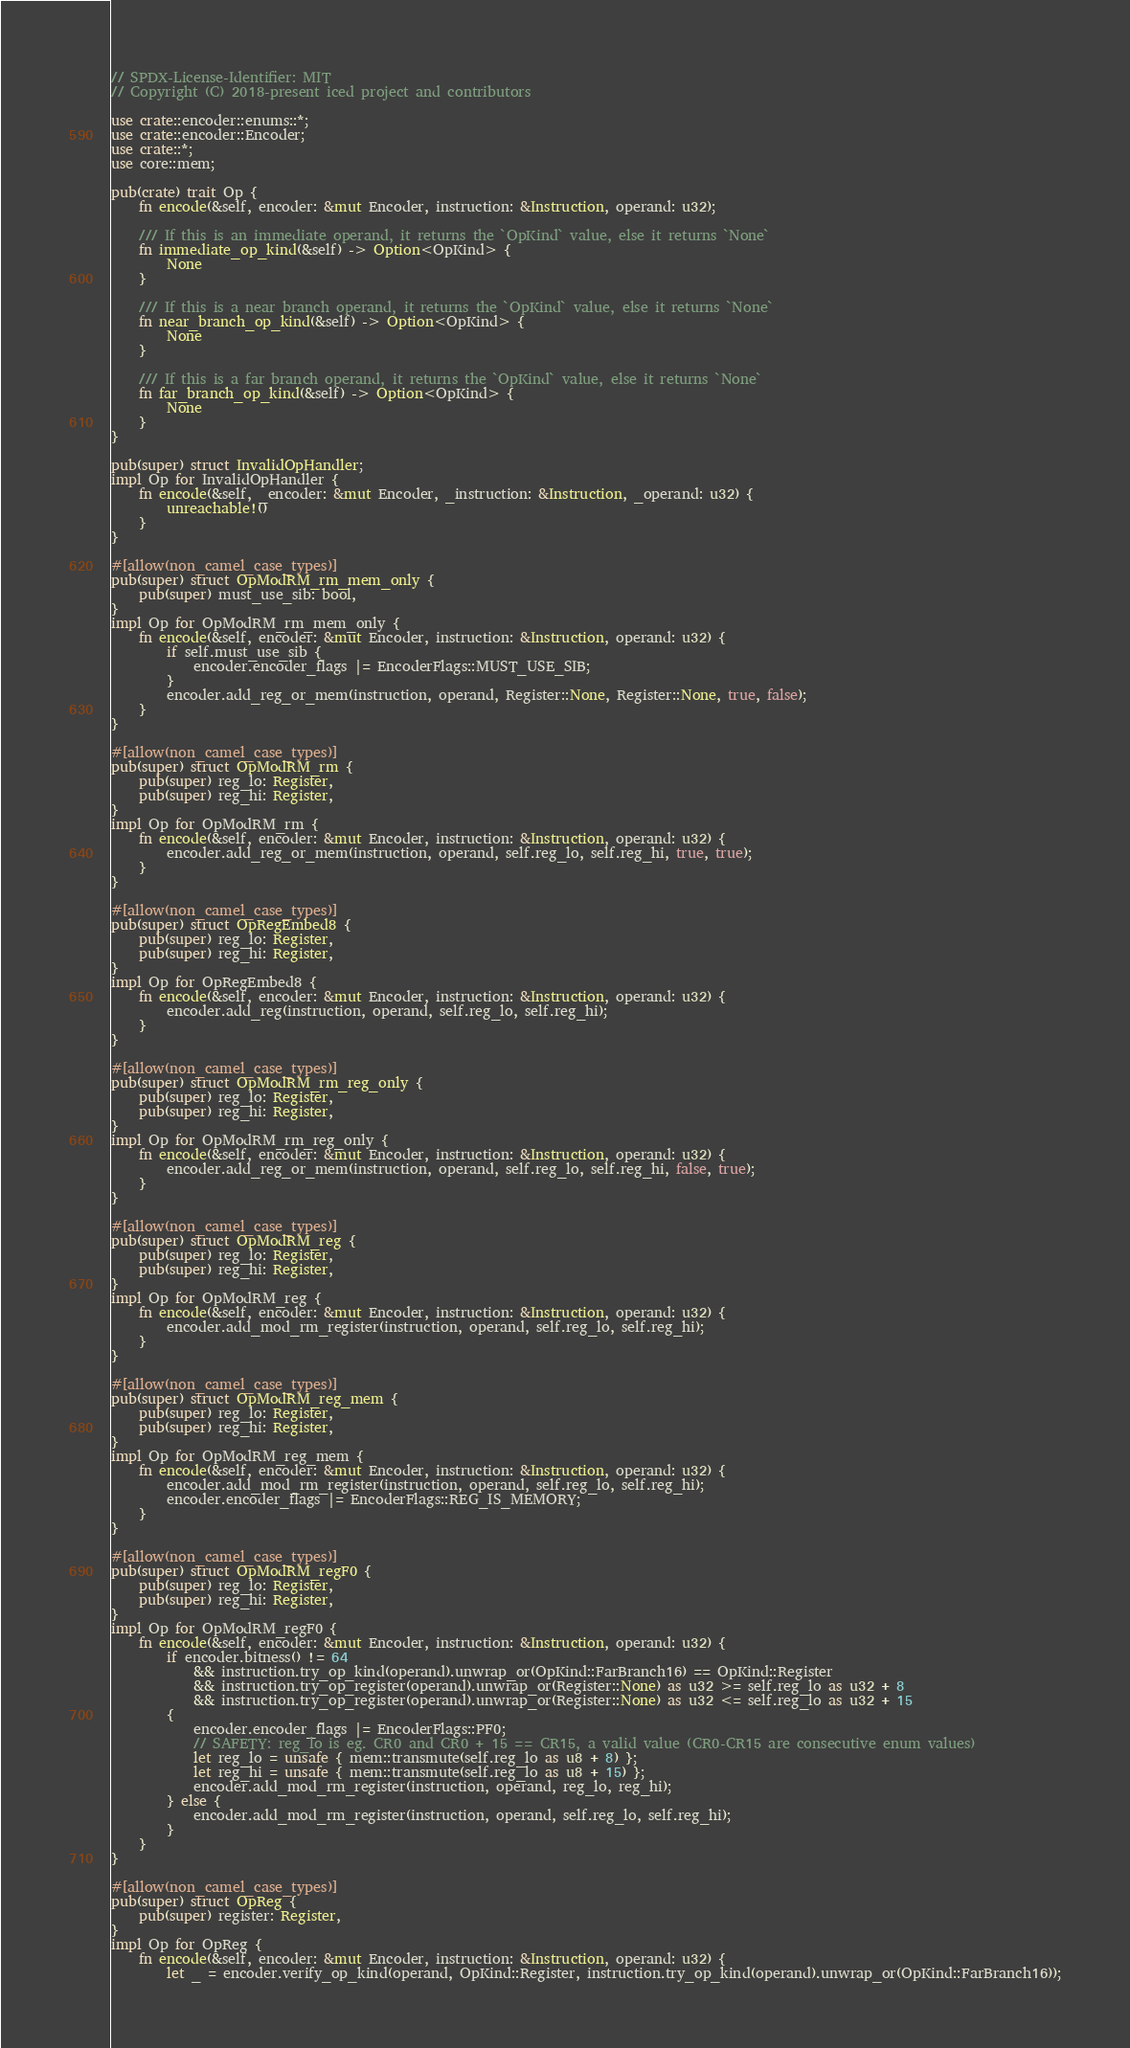<code> <loc_0><loc_0><loc_500><loc_500><_Rust_>// SPDX-License-Identifier: MIT
// Copyright (C) 2018-present iced project and contributors

use crate::encoder::enums::*;
use crate::encoder::Encoder;
use crate::*;
use core::mem;

pub(crate) trait Op {
	fn encode(&self, encoder: &mut Encoder, instruction: &Instruction, operand: u32);

	/// If this is an immediate operand, it returns the `OpKind` value, else it returns `None`
	fn immediate_op_kind(&self) -> Option<OpKind> {
		None
	}

	/// If this is a near branch operand, it returns the `OpKind` value, else it returns `None`
	fn near_branch_op_kind(&self) -> Option<OpKind> {
		None
	}

	/// If this is a far branch operand, it returns the `OpKind` value, else it returns `None`
	fn far_branch_op_kind(&self) -> Option<OpKind> {
		None
	}
}

pub(super) struct InvalidOpHandler;
impl Op for InvalidOpHandler {
	fn encode(&self, _encoder: &mut Encoder, _instruction: &Instruction, _operand: u32) {
		unreachable!()
	}
}

#[allow(non_camel_case_types)]
pub(super) struct OpModRM_rm_mem_only {
	pub(super) must_use_sib: bool,
}
impl Op for OpModRM_rm_mem_only {
	fn encode(&self, encoder: &mut Encoder, instruction: &Instruction, operand: u32) {
		if self.must_use_sib {
			encoder.encoder_flags |= EncoderFlags::MUST_USE_SIB;
		}
		encoder.add_reg_or_mem(instruction, operand, Register::None, Register::None, true, false);
	}
}

#[allow(non_camel_case_types)]
pub(super) struct OpModRM_rm {
	pub(super) reg_lo: Register,
	pub(super) reg_hi: Register,
}
impl Op for OpModRM_rm {
	fn encode(&self, encoder: &mut Encoder, instruction: &Instruction, operand: u32) {
		encoder.add_reg_or_mem(instruction, operand, self.reg_lo, self.reg_hi, true, true);
	}
}

#[allow(non_camel_case_types)]
pub(super) struct OpRegEmbed8 {
	pub(super) reg_lo: Register,
	pub(super) reg_hi: Register,
}
impl Op for OpRegEmbed8 {
	fn encode(&self, encoder: &mut Encoder, instruction: &Instruction, operand: u32) {
		encoder.add_reg(instruction, operand, self.reg_lo, self.reg_hi);
	}
}

#[allow(non_camel_case_types)]
pub(super) struct OpModRM_rm_reg_only {
	pub(super) reg_lo: Register,
	pub(super) reg_hi: Register,
}
impl Op for OpModRM_rm_reg_only {
	fn encode(&self, encoder: &mut Encoder, instruction: &Instruction, operand: u32) {
		encoder.add_reg_or_mem(instruction, operand, self.reg_lo, self.reg_hi, false, true);
	}
}

#[allow(non_camel_case_types)]
pub(super) struct OpModRM_reg {
	pub(super) reg_lo: Register,
	pub(super) reg_hi: Register,
}
impl Op for OpModRM_reg {
	fn encode(&self, encoder: &mut Encoder, instruction: &Instruction, operand: u32) {
		encoder.add_mod_rm_register(instruction, operand, self.reg_lo, self.reg_hi);
	}
}

#[allow(non_camel_case_types)]
pub(super) struct OpModRM_reg_mem {
	pub(super) reg_lo: Register,
	pub(super) reg_hi: Register,
}
impl Op for OpModRM_reg_mem {
	fn encode(&self, encoder: &mut Encoder, instruction: &Instruction, operand: u32) {
		encoder.add_mod_rm_register(instruction, operand, self.reg_lo, self.reg_hi);
		encoder.encoder_flags |= EncoderFlags::REG_IS_MEMORY;
	}
}

#[allow(non_camel_case_types)]
pub(super) struct OpModRM_regF0 {
	pub(super) reg_lo: Register,
	pub(super) reg_hi: Register,
}
impl Op for OpModRM_regF0 {
	fn encode(&self, encoder: &mut Encoder, instruction: &Instruction, operand: u32) {
		if encoder.bitness() != 64
			&& instruction.try_op_kind(operand).unwrap_or(OpKind::FarBranch16) == OpKind::Register
			&& instruction.try_op_register(operand).unwrap_or(Register::None) as u32 >= self.reg_lo as u32 + 8
			&& instruction.try_op_register(operand).unwrap_or(Register::None) as u32 <= self.reg_lo as u32 + 15
		{
			encoder.encoder_flags |= EncoderFlags::PF0;
			// SAFETY: reg_lo is eg. CR0 and CR0 + 15 == CR15, a valid value (CR0-CR15 are consecutive enum values)
			let reg_lo = unsafe { mem::transmute(self.reg_lo as u8 + 8) };
			let reg_hi = unsafe { mem::transmute(self.reg_lo as u8 + 15) };
			encoder.add_mod_rm_register(instruction, operand, reg_lo, reg_hi);
		} else {
			encoder.add_mod_rm_register(instruction, operand, self.reg_lo, self.reg_hi);
		}
	}
}

#[allow(non_camel_case_types)]
pub(super) struct OpReg {
	pub(super) register: Register,
}
impl Op for OpReg {
	fn encode(&self, encoder: &mut Encoder, instruction: &Instruction, operand: u32) {
		let _ = encoder.verify_op_kind(operand, OpKind::Register, instruction.try_op_kind(operand).unwrap_or(OpKind::FarBranch16));</code> 